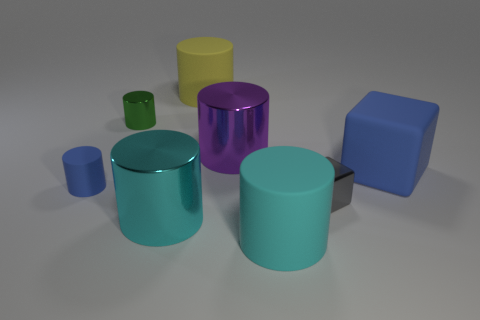Could there be a symbolic meaning behind the arrangement of shapes and colors? Certainly, the arrangement can be perceived as a representation of harmony and diversity, with different shapes and colors coexisting peacefully. The layout might symbolize societal diversity or the variety found in nature. The interpretation can be quite subjective, reflecting the viewer's perspective or experiences. 